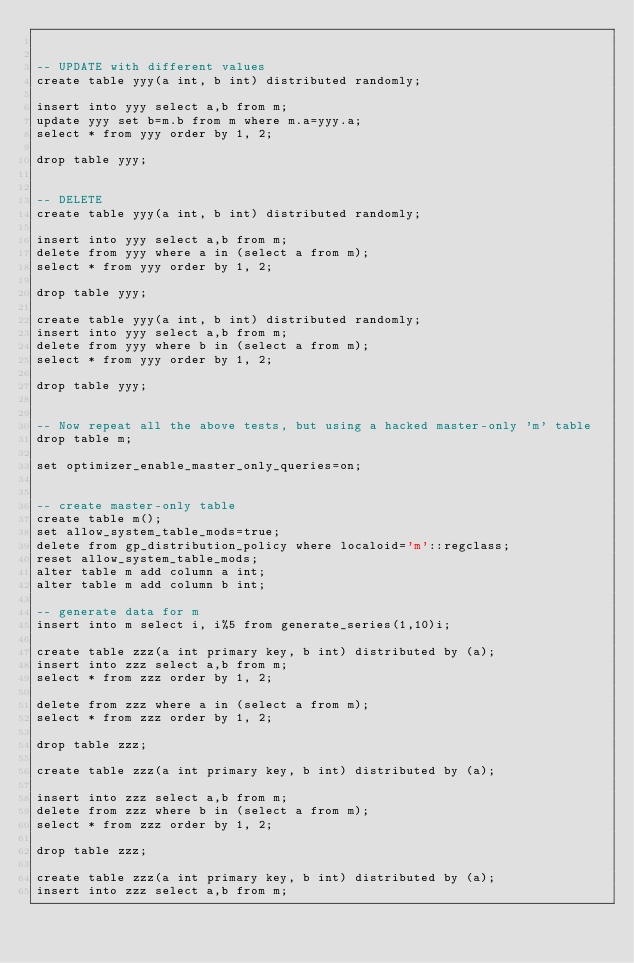Convert code to text. <code><loc_0><loc_0><loc_500><loc_500><_SQL_>

-- UPDATE with different values
create table yyy(a int, b int) distributed randomly;

insert into yyy select a,b from m;
update yyy set b=m.b from m where m.a=yyy.a;
select * from yyy order by 1, 2;

drop table yyy;


-- DELETE
create table yyy(a int, b int) distributed randomly;

insert into yyy select a,b from m;
delete from yyy where a in (select a from m);
select * from yyy order by 1, 2;

drop table yyy;

create table yyy(a int, b int) distributed randomly;
insert into yyy select a,b from m;
delete from yyy where b in (select a from m);
select * from yyy order by 1, 2;

drop table yyy;


-- Now repeat all the above tests, but using a hacked master-only 'm' table
drop table m;

set optimizer_enable_master_only_queries=on;


-- create master-only table
create table m();
set allow_system_table_mods=true;
delete from gp_distribution_policy where localoid='m'::regclass;
reset allow_system_table_mods;
alter table m add column a int;
alter table m add column b int;

-- generate data for m
insert into m select i, i%5 from generate_series(1,10)i;

create table zzz(a int primary key, b int) distributed by (a);
insert into zzz select a,b from m;
select * from zzz order by 1, 2;

delete from zzz where a in (select a from m);
select * from zzz order by 1, 2;

drop table zzz;

create table zzz(a int primary key, b int) distributed by (a);

insert into zzz select a,b from m;
delete from zzz where b in (select a from m);
select * from zzz order by 1, 2;

drop table zzz;

create table zzz(a int primary key, b int) distributed by (a);
insert into zzz select a,b from m;
</code> 